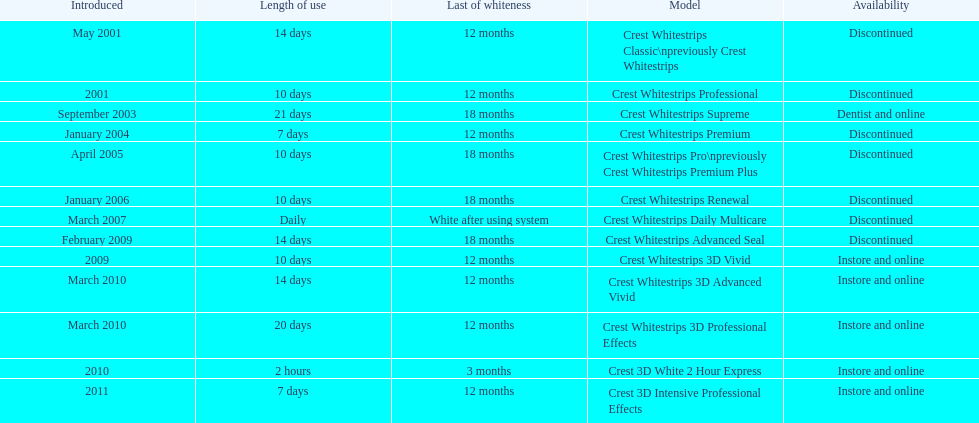Is each white strip discontinued? No. 